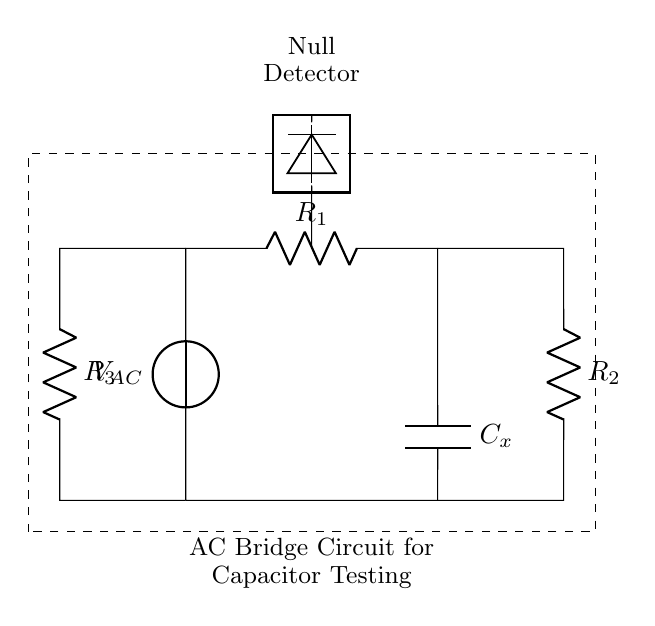What type of circuit is this? This circuit is an AC bridge circuit, specifically designed for testing capacitors. The presence of multiple resistors and a capacitor indicates it is set up to measure the capacitance through impedance balancing.
Answer: AC bridge circuit What does the null detector do? The null detector measures the potential difference between two points in the circuit. When the bridge is balanced, the detector shows no voltage, indicating that the capacitor's value is accurately measured against known resistances.
Answer: Measures voltage How many resistors are in the circuit? There are three resistors in the circuit: R1, R2, and R3. They are arranged to create paths for current and help balance the bridge.
Answer: Three What is the purpose of the capacitor labeled Cx? The capacitor Cx is the unknown capacitor being tested. Its capacitance will be determined by balancing the circuit against known resistances.
Answer: Unknown capacitor What does the dashed rectangle represent? The dashed rectangle encloses the entire AC bridge circuit, indicating the area of interest for testing and analysis, separating it from other elements in the surrounding context.
Answer: Circuit boundary What happens when the bridge is balanced? When the bridge is balanced, the null detector reads zero, indicating that the reactance of the capacitor Cx matches the ratio of resistances in the circuit, allowing for accurate capacitance measurement.
Answer: Zero reading What type of source is used in the circuit? The circuit uses an alternating current (AC) voltage source, which is necessary for the operation of the bridge and the capacitive testing performed within the circuit.
Answer: AC voltage source 